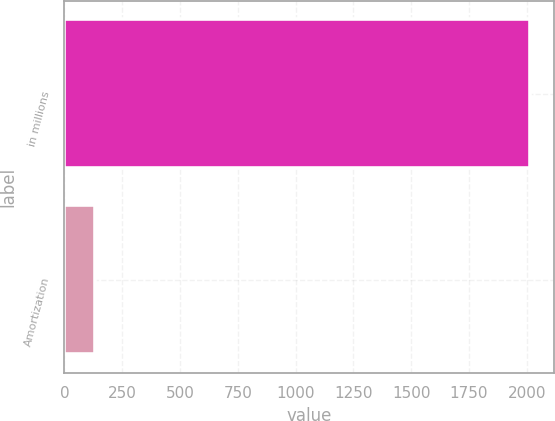Convert chart to OTSL. <chart><loc_0><loc_0><loc_500><loc_500><bar_chart><fcel>in millions<fcel>Amortization<nl><fcel>2015<fcel>132<nl></chart> 